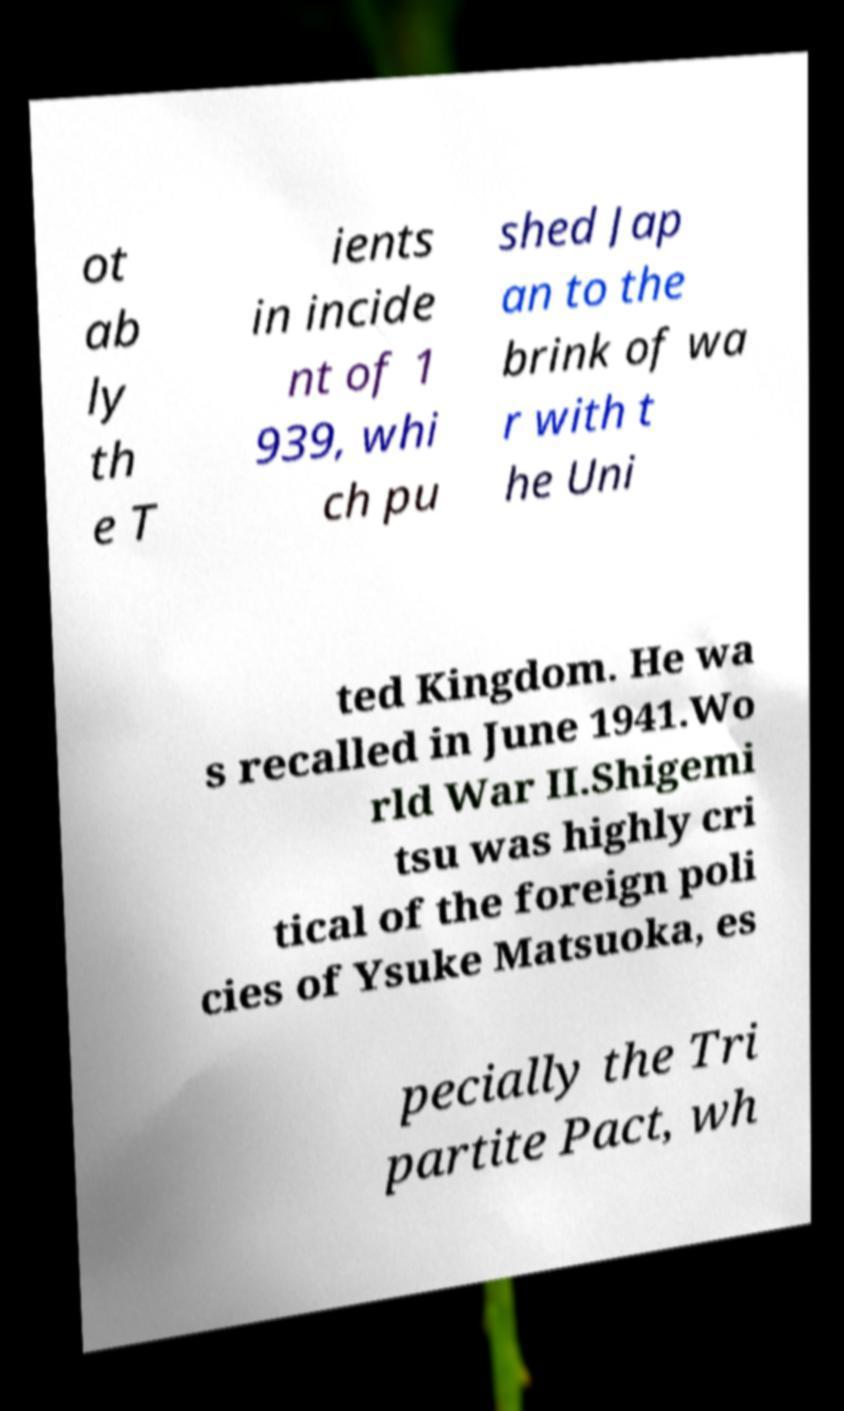For documentation purposes, I need the text within this image transcribed. Could you provide that? ot ab ly th e T ients in incide nt of 1 939, whi ch pu shed Jap an to the brink of wa r with t he Uni ted Kingdom. He wa s recalled in June 1941.Wo rld War II.Shigemi tsu was highly cri tical of the foreign poli cies of Ysuke Matsuoka, es pecially the Tri partite Pact, wh 